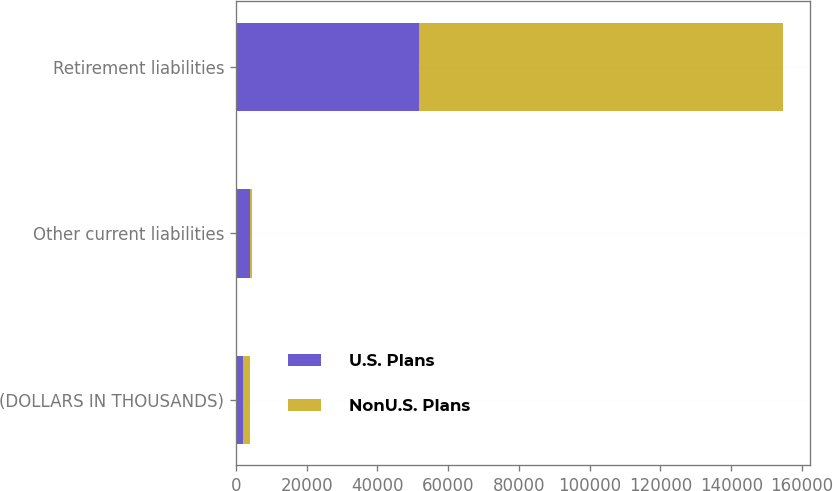Convert chart. <chart><loc_0><loc_0><loc_500><loc_500><stacked_bar_chart><ecel><fcel>(DOLLARS IN THOUSANDS)<fcel>Other current liabilities<fcel>Retirement liabilities<nl><fcel>U.S. Plans<fcel>2016<fcel>4027<fcel>51684<nl><fcel>NonU.S. Plans<fcel>2016<fcel>557<fcel>102871<nl></chart> 